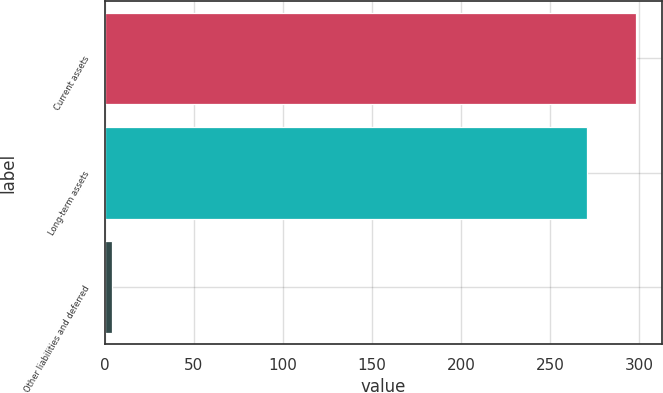Convert chart to OTSL. <chart><loc_0><loc_0><loc_500><loc_500><bar_chart><fcel>Current assets<fcel>Long-term assets<fcel>Other liabilities and deferred<nl><fcel>298.2<fcel>271<fcel>4<nl></chart> 